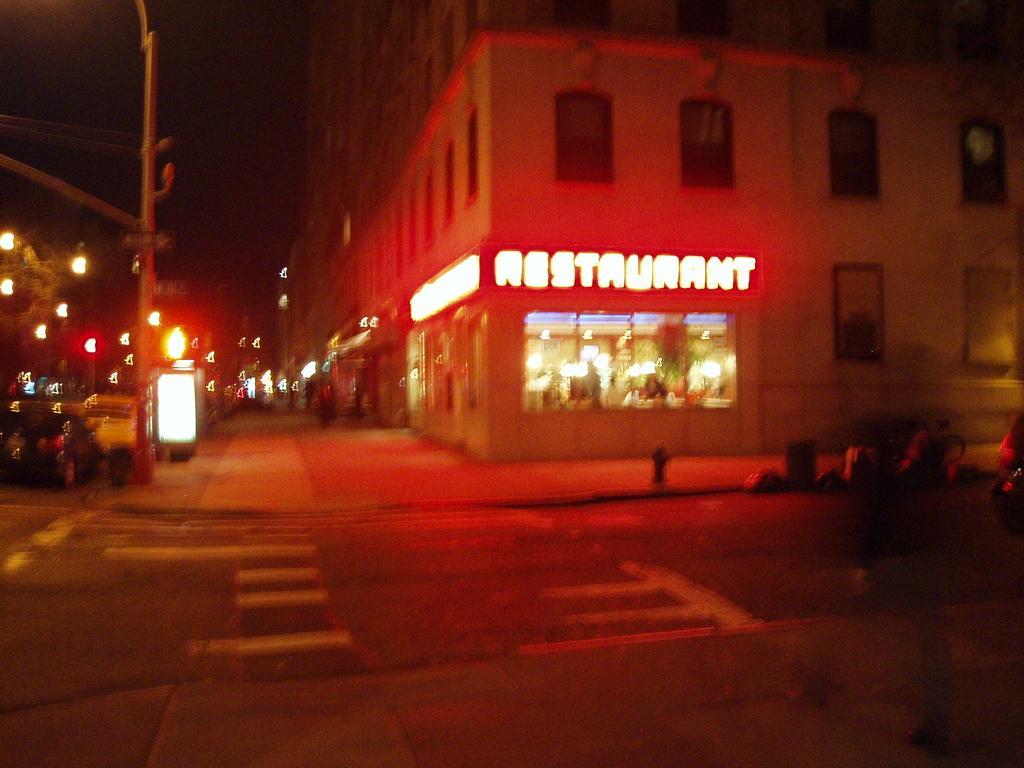Could you give a brief overview of what you see in this image? It is a blur view. In this image, we can see buildings with walls and windows. Few vehicles are on the road. Here we can see pole, sign boards, store. 